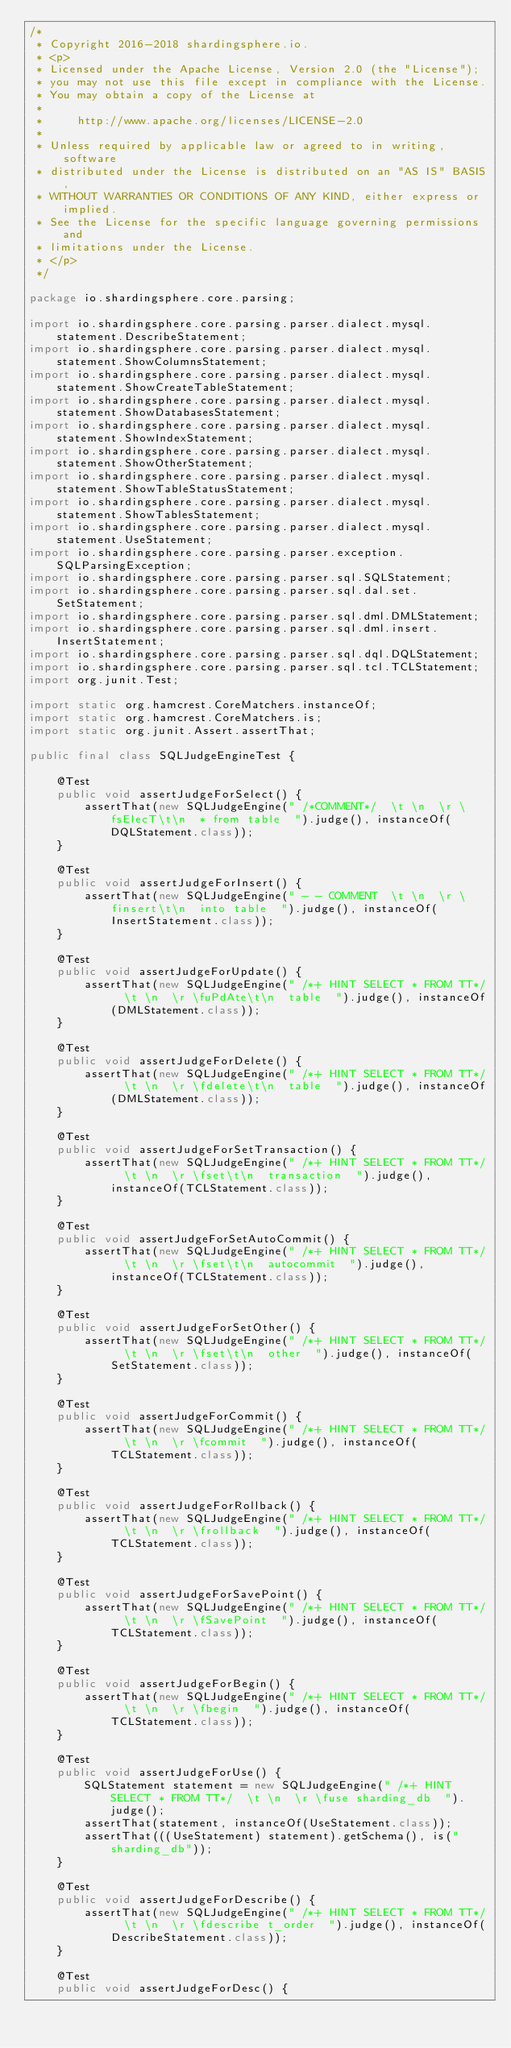<code> <loc_0><loc_0><loc_500><loc_500><_Java_>/*
 * Copyright 2016-2018 shardingsphere.io.
 * <p>
 * Licensed under the Apache License, Version 2.0 (the "License");
 * you may not use this file except in compliance with the License.
 * You may obtain a copy of the License at
 *
 *     http://www.apache.org/licenses/LICENSE-2.0
 *
 * Unless required by applicable law or agreed to in writing, software
 * distributed under the License is distributed on an "AS IS" BASIS,
 * WITHOUT WARRANTIES OR CONDITIONS OF ANY KIND, either express or implied.
 * See the License for the specific language governing permissions and
 * limitations under the License.
 * </p>
 */

package io.shardingsphere.core.parsing;

import io.shardingsphere.core.parsing.parser.dialect.mysql.statement.DescribeStatement;
import io.shardingsphere.core.parsing.parser.dialect.mysql.statement.ShowColumnsStatement;
import io.shardingsphere.core.parsing.parser.dialect.mysql.statement.ShowCreateTableStatement;
import io.shardingsphere.core.parsing.parser.dialect.mysql.statement.ShowDatabasesStatement;
import io.shardingsphere.core.parsing.parser.dialect.mysql.statement.ShowIndexStatement;
import io.shardingsphere.core.parsing.parser.dialect.mysql.statement.ShowOtherStatement;
import io.shardingsphere.core.parsing.parser.dialect.mysql.statement.ShowTableStatusStatement;
import io.shardingsphere.core.parsing.parser.dialect.mysql.statement.ShowTablesStatement;
import io.shardingsphere.core.parsing.parser.dialect.mysql.statement.UseStatement;
import io.shardingsphere.core.parsing.parser.exception.SQLParsingException;
import io.shardingsphere.core.parsing.parser.sql.SQLStatement;
import io.shardingsphere.core.parsing.parser.sql.dal.set.SetStatement;
import io.shardingsphere.core.parsing.parser.sql.dml.DMLStatement;
import io.shardingsphere.core.parsing.parser.sql.dml.insert.InsertStatement;
import io.shardingsphere.core.parsing.parser.sql.dql.DQLStatement;
import io.shardingsphere.core.parsing.parser.sql.tcl.TCLStatement;
import org.junit.Test;

import static org.hamcrest.CoreMatchers.instanceOf;
import static org.hamcrest.CoreMatchers.is;
import static org.junit.Assert.assertThat;

public final class SQLJudgeEngineTest {
    
    @Test
    public void assertJudgeForSelect() {
        assertThat(new SQLJudgeEngine(" /*COMMENT*/  \t \n  \r \fsElecT\t\n  * from table  ").judge(), instanceOf(DQLStatement.class));
    }
    
    @Test
    public void assertJudgeForInsert() {
        assertThat(new SQLJudgeEngine(" - - COMMENT  \t \n  \r \finsert\t\n  into table  ").judge(), instanceOf(InsertStatement.class));
    }
    
    @Test
    public void assertJudgeForUpdate() {
        assertThat(new SQLJudgeEngine(" /*+ HINT SELECT * FROM TT*/  \t \n  \r \fuPdAte\t\n  table  ").judge(), instanceOf(DMLStatement.class));
    }
    
    @Test
    public void assertJudgeForDelete() {
        assertThat(new SQLJudgeEngine(" /*+ HINT SELECT * FROM TT*/  \t \n  \r \fdelete\t\n  table  ").judge(), instanceOf(DMLStatement.class));
    }
    
    @Test
    public void assertJudgeForSetTransaction() {
        assertThat(new SQLJudgeEngine(" /*+ HINT SELECT * FROM TT*/  \t \n  \r \fset\t\n  transaction  ").judge(), instanceOf(TCLStatement.class));
    }
    
    @Test
    public void assertJudgeForSetAutoCommit() {
        assertThat(new SQLJudgeEngine(" /*+ HINT SELECT * FROM TT*/  \t \n  \r \fset\t\n  autocommit  ").judge(), instanceOf(TCLStatement.class));
    }
    
    @Test
    public void assertJudgeForSetOther() {
        assertThat(new SQLJudgeEngine(" /*+ HINT SELECT * FROM TT*/  \t \n  \r \fset\t\n  other  ").judge(), instanceOf(SetStatement.class));
    }
    
    @Test
    public void assertJudgeForCommit() {
        assertThat(new SQLJudgeEngine(" /*+ HINT SELECT * FROM TT*/  \t \n  \r \fcommit  ").judge(), instanceOf(TCLStatement.class));
    }
    
    @Test
    public void assertJudgeForRollback() {
        assertThat(new SQLJudgeEngine(" /*+ HINT SELECT * FROM TT*/  \t \n  \r \frollback  ").judge(), instanceOf(TCLStatement.class));
    }
    
    @Test
    public void assertJudgeForSavePoint() {
        assertThat(new SQLJudgeEngine(" /*+ HINT SELECT * FROM TT*/  \t \n  \r \fSavePoint  ").judge(), instanceOf(TCLStatement.class));
    }
    
    @Test
    public void assertJudgeForBegin() {
        assertThat(new SQLJudgeEngine(" /*+ HINT SELECT * FROM TT*/  \t \n  \r \fbegin  ").judge(), instanceOf(TCLStatement.class));
    }
    
    @Test
    public void assertJudgeForUse() {
        SQLStatement statement = new SQLJudgeEngine(" /*+ HINT SELECT * FROM TT*/  \t \n  \r \fuse sharding_db  ").judge();
        assertThat(statement, instanceOf(UseStatement.class));
        assertThat(((UseStatement) statement).getSchema(), is("sharding_db"));
    }
    
    @Test
    public void assertJudgeForDescribe() {
        assertThat(new SQLJudgeEngine(" /*+ HINT SELECT * FROM TT*/  \t \n  \r \fdescribe t_order  ").judge(), instanceOf(DescribeStatement.class));
    }
    
    @Test
    public void assertJudgeForDesc() {</code> 